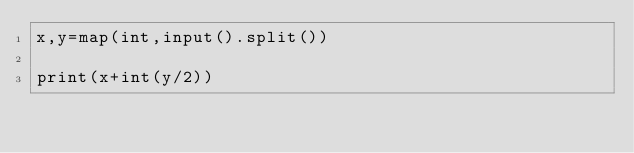Convert code to text. <code><loc_0><loc_0><loc_500><loc_500><_Python_>x,y=map(int,input().split())

print(x+int(y/2))</code> 